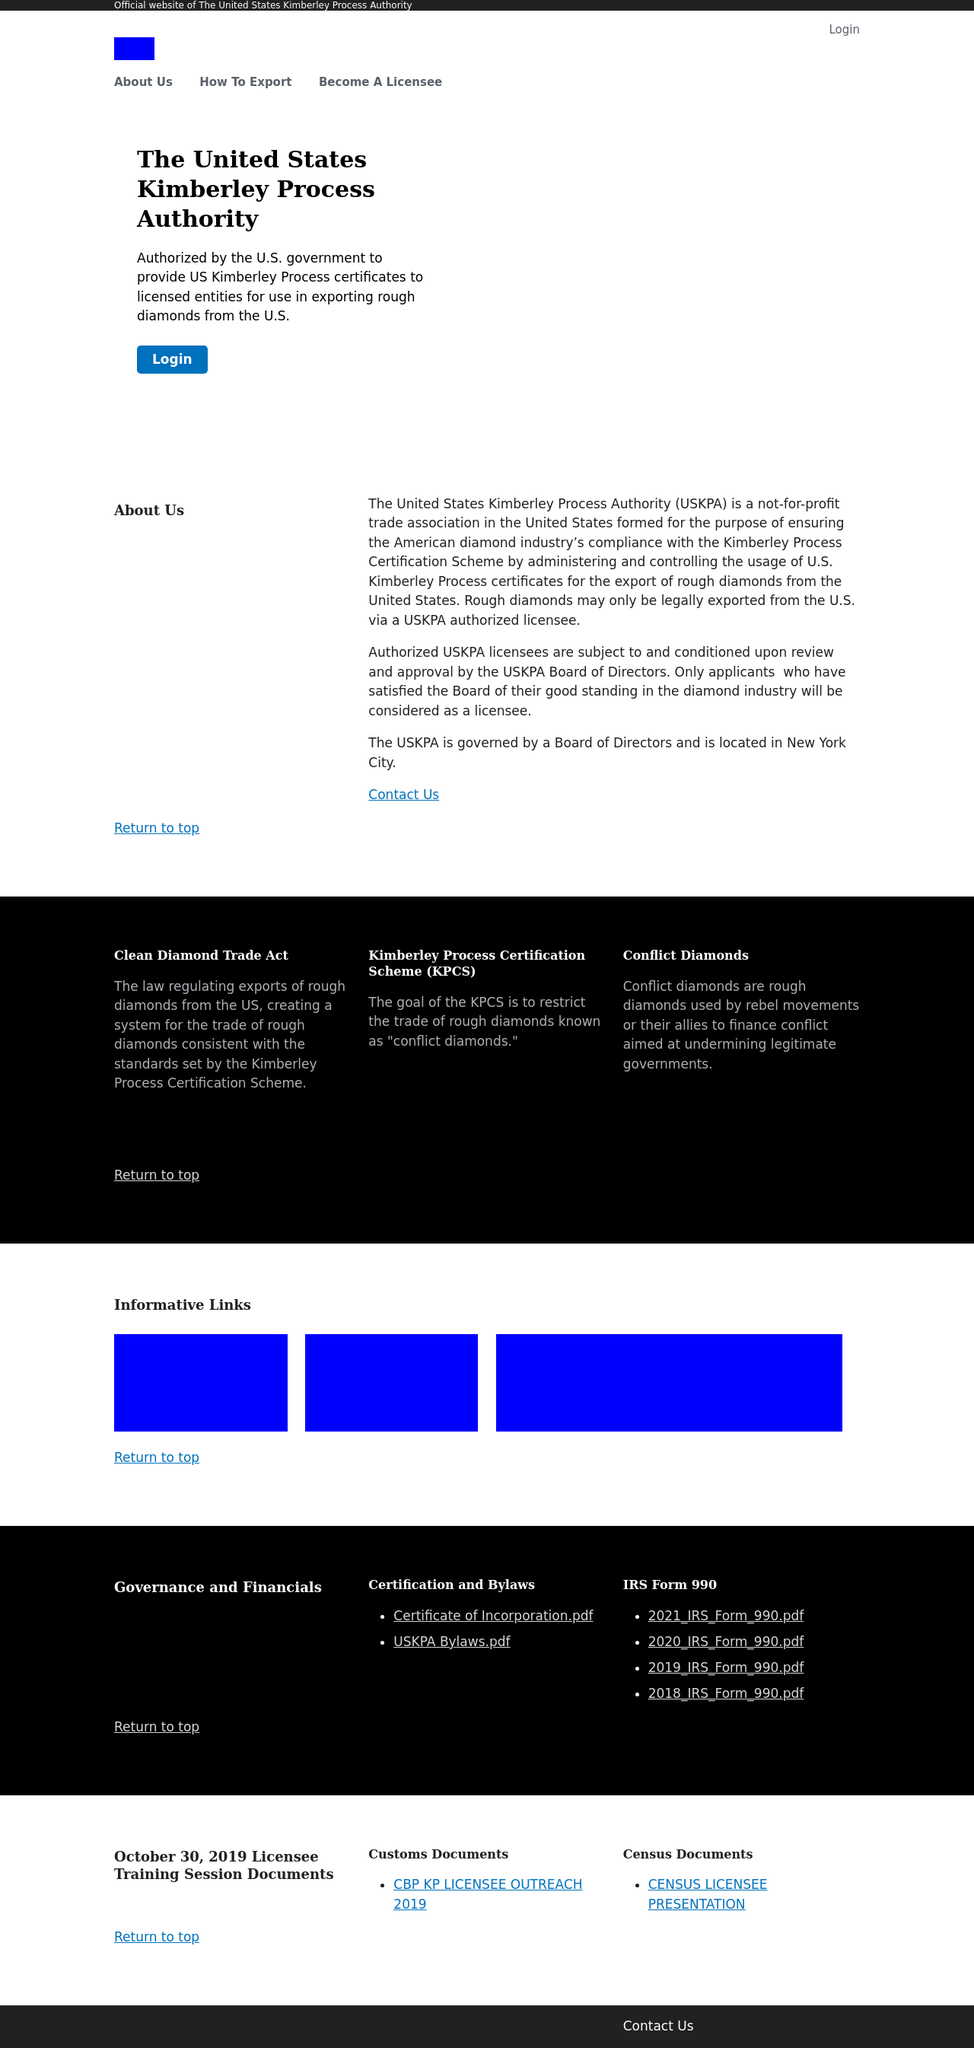Could you guide me through the process of developing this website with HTML? To develop a website like the one shown in the image, you would start by creating a basic HTML structure, defining the sections visible such as the header, main content area, and footer. You'd use semantic HTML tags like <header>, <section>, <footer>, and within those, use <nav> for navigation, <div> for layout control, and <a> for links. Each section would be styled with CSS to match the aesthetic we see: a monochrome color scheme with blue highlights, and a clean, professional layout. Javascript might be employed for interactive elements like the navigation menu. 